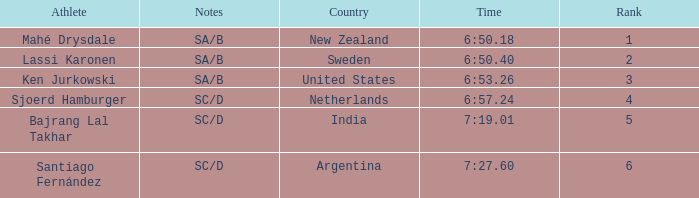What is the highest rank for the team that raced a time of 6:50.40? 2.0. 